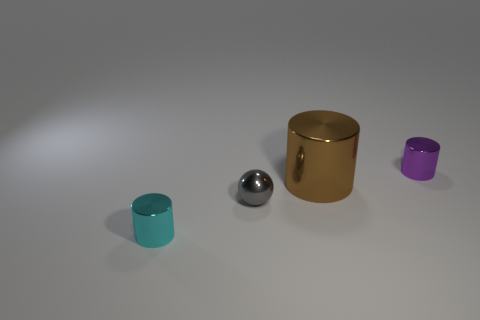Can you describe the colors and shapes of the objects present? Certainly! There are four objects with distinct colors and shapes. From left to right, the first is a small, teal cylinder; the second, a silver sphere; the third, a larger brown cylinder with a gold reflective finish; and finally, a small purple cylinder. 